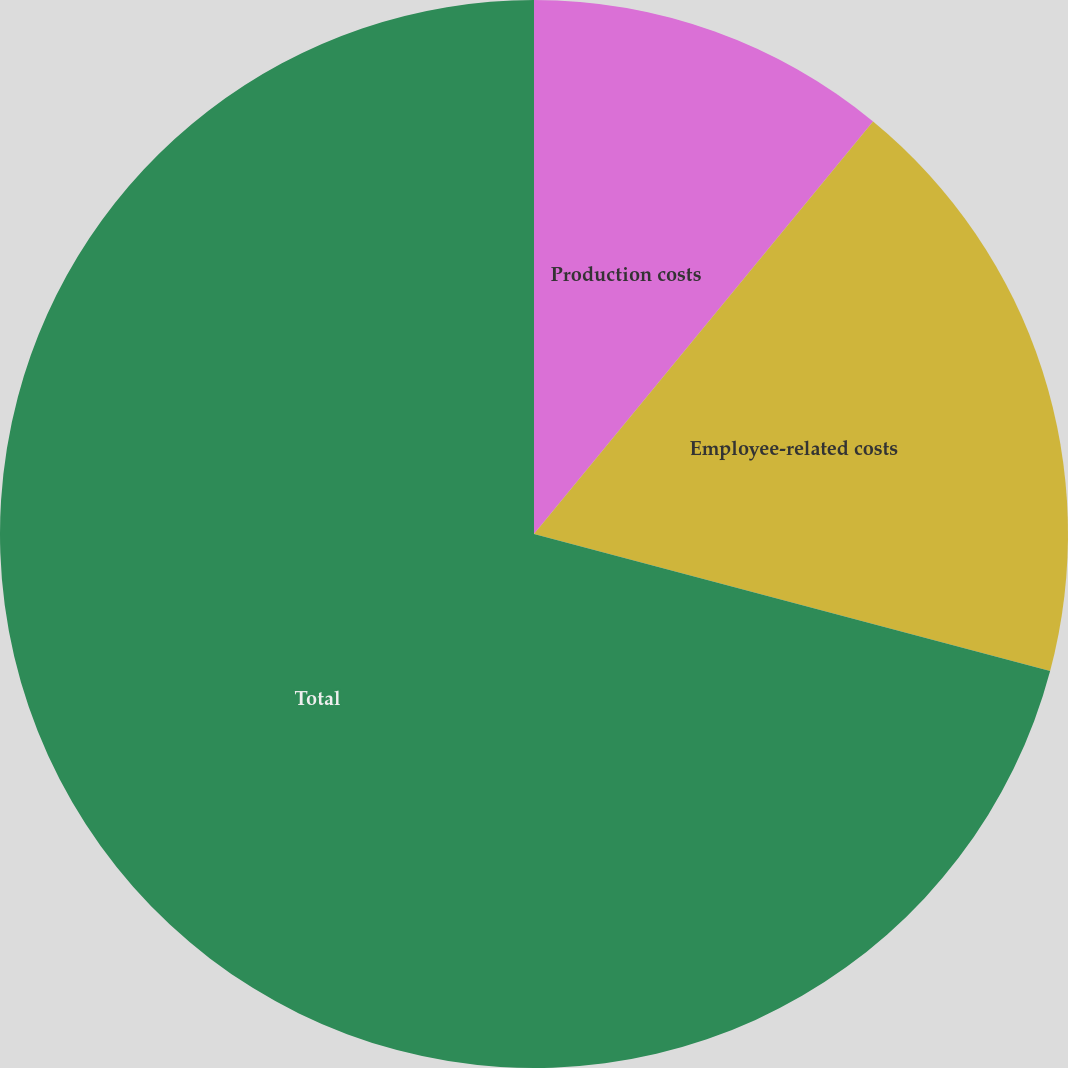Convert chart. <chart><loc_0><loc_0><loc_500><loc_500><pie_chart><fcel>Production costs<fcel>Employee-related costs<fcel>Total<nl><fcel>10.95%<fcel>18.18%<fcel>70.87%<nl></chart> 